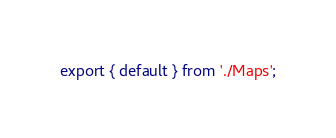Convert code to text. <code><loc_0><loc_0><loc_500><loc_500><_JavaScript_>export { default } from './Maps';</code> 